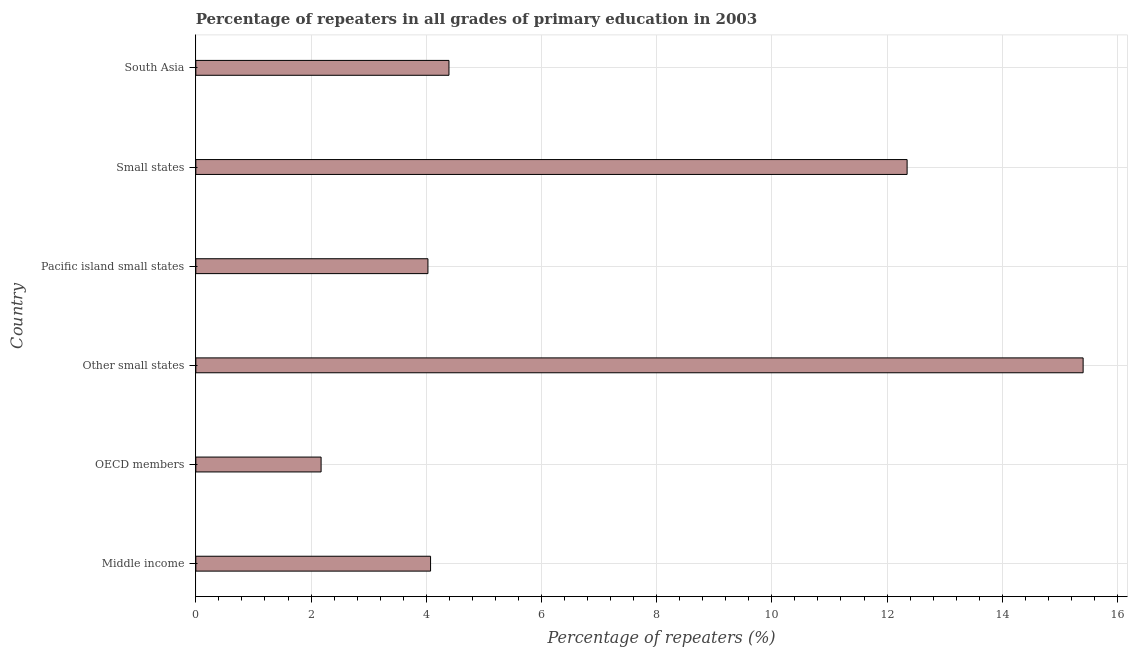Does the graph contain grids?
Give a very brief answer. Yes. What is the title of the graph?
Your response must be concise. Percentage of repeaters in all grades of primary education in 2003. What is the label or title of the X-axis?
Offer a very short reply. Percentage of repeaters (%). What is the percentage of repeaters in primary education in Middle income?
Offer a terse response. 4.08. Across all countries, what is the maximum percentage of repeaters in primary education?
Ensure brevity in your answer.  15.4. Across all countries, what is the minimum percentage of repeaters in primary education?
Give a very brief answer. 2.17. In which country was the percentage of repeaters in primary education maximum?
Your answer should be very brief. Other small states. What is the sum of the percentage of repeaters in primary education?
Provide a short and direct response. 42.42. What is the difference between the percentage of repeaters in primary education in Other small states and South Asia?
Your answer should be compact. 11.01. What is the average percentage of repeaters in primary education per country?
Your answer should be compact. 7.07. What is the median percentage of repeaters in primary education?
Ensure brevity in your answer.  4.23. In how many countries, is the percentage of repeaters in primary education greater than 0.8 %?
Keep it short and to the point. 6. What is the ratio of the percentage of repeaters in primary education in Pacific island small states to that in Small states?
Offer a terse response. 0.33. Is the percentage of repeaters in primary education in OECD members less than that in Small states?
Keep it short and to the point. Yes. What is the difference between the highest and the second highest percentage of repeaters in primary education?
Offer a very short reply. 3.06. What is the difference between the highest and the lowest percentage of repeaters in primary education?
Provide a short and direct response. 13.23. In how many countries, is the percentage of repeaters in primary education greater than the average percentage of repeaters in primary education taken over all countries?
Give a very brief answer. 2. How many bars are there?
Your answer should be compact. 6. How many countries are there in the graph?
Keep it short and to the point. 6. Are the values on the major ticks of X-axis written in scientific E-notation?
Make the answer very short. No. What is the Percentage of repeaters (%) of Middle income?
Give a very brief answer. 4.08. What is the Percentage of repeaters (%) of OECD members?
Provide a short and direct response. 2.17. What is the Percentage of repeaters (%) in Other small states?
Provide a succinct answer. 15.4. What is the Percentage of repeaters (%) in Pacific island small states?
Offer a very short reply. 4.03. What is the Percentage of repeaters (%) of Small states?
Offer a very short reply. 12.35. What is the Percentage of repeaters (%) in South Asia?
Keep it short and to the point. 4.39. What is the difference between the Percentage of repeaters (%) in Middle income and OECD members?
Provide a short and direct response. 1.9. What is the difference between the Percentage of repeaters (%) in Middle income and Other small states?
Your answer should be very brief. -11.33. What is the difference between the Percentage of repeaters (%) in Middle income and Pacific island small states?
Give a very brief answer. 0.05. What is the difference between the Percentage of repeaters (%) in Middle income and Small states?
Your response must be concise. -8.27. What is the difference between the Percentage of repeaters (%) in Middle income and South Asia?
Your response must be concise. -0.32. What is the difference between the Percentage of repeaters (%) in OECD members and Other small states?
Keep it short and to the point. -13.23. What is the difference between the Percentage of repeaters (%) in OECD members and Pacific island small states?
Ensure brevity in your answer.  -1.85. What is the difference between the Percentage of repeaters (%) in OECD members and Small states?
Provide a short and direct response. -10.17. What is the difference between the Percentage of repeaters (%) in OECD members and South Asia?
Give a very brief answer. -2.22. What is the difference between the Percentage of repeaters (%) in Other small states and Pacific island small states?
Provide a short and direct response. 11.37. What is the difference between the Percentage of repeaters (%) in Other small states and Small states?
Make the answer very short. 3.06. What is the difference between the Percentage of repeaters (%) in Other small states and South Asia?
Give a very brief answer. 11.01. What is the difference between the Percentage of repeaters (%) in Pacific island small states and Small states?
Offer a terse response. -8.32. What is the difference between the Percentage of repeaters (%) in Pacific island small states and South Asia?
Provide a succinct answer. -0.37. What is the difference between the Percentage of repeaters (%) in Small states and South Asia?
Ensure brevity in your answer.  7.95. What is the ratio of the Percentage of repeaters (%) in Middle income to that in OECD members?
Provide a succinct answer. 1.87. What is the ratio of the Percentage of repeaters (%) in Middle income to that in Other small states?
Offer a very short reply. 0.27. What is the ratio of the Percentage of repeaters (%) in Middle income to that in Pacific island small states?
Ensure brevity in your answer.  1.01. What is the ratio of the Percentage of repeaters (%) in Middle income to that in Small states?
Ensure brevity in your answer.  0.33. What is the ratio of the Percentage of repeaters (%) in Middle income to that in South Asia?
Offer a terse response. 0.93. What is the ratio of the Percentage of repeaters (%) in OECD members to that in Other small states?
Your response must be concise. 0.14. What is the ratio of the Percentage of repeaters (%) in OECD members to that in Pacific island small states?
Provide a succinct answer. 0.54. What is the ratio of the Percentage of repeaters (%) in OECD members to that in Small states?
Your answer should be very brief. 0.18. What is the ratio of the Percentage of repeaters (%) in OECD members to that in South Asia?
Offer a terse response. 0.49. What is the ratio of the Percentage of repeaters (%) in Other small states to that in Pacific island small states?
Your answer should be compact. 3.82. What is the ratio of the Percentage of repeaters (%) in Other small states to that in Small states?
Your response must be concise. 1.25. What is the ratio of the Percentage of repeaters (%) in Other small states to that in South Asia?
Your response must be concise. 3.5. What is the ratio of the Percentage of repeaters (%) in Pacific island small states to that in Small states?
Provide a succinct answer. 0.33. What is the ratio of the Percentage of repeaters (%) in Pacific island small states to that in South Asia?
Offer a very short reply. 0.92. What is the ratio of the Percentage of repeaters (%) in Small states to that in South Asia?
Make the answer very short. 2.81. 